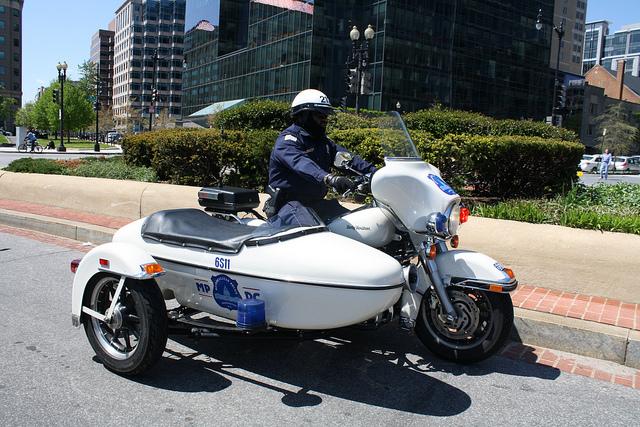Is this a cop riding a motorcycle?
Answer briefly. Yes. What color is his helmet?
Answer briefly. White. What color is the man outfit in parking lot?
Short answer required. Blue. 